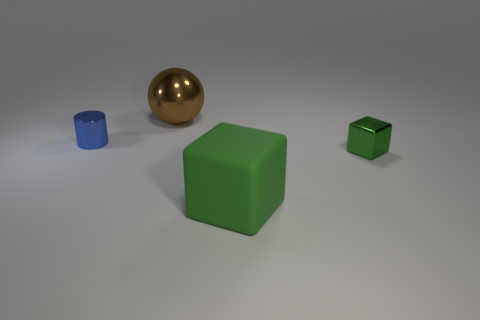Add 2 small metal cubes. How many objects exist? 6 Subtract all cylinders. How many objects are left? 3 Subtract 1 brown balls. How many objects are left? 3 Subtract all big metal balls. Subtract all big brown cylinders. How many objects are left? 3 Add 2 small shiny cylinders. How many small shiny cylinders are left? 3 Add 1 big blue matte things. How many big blue matte things exist? 1 